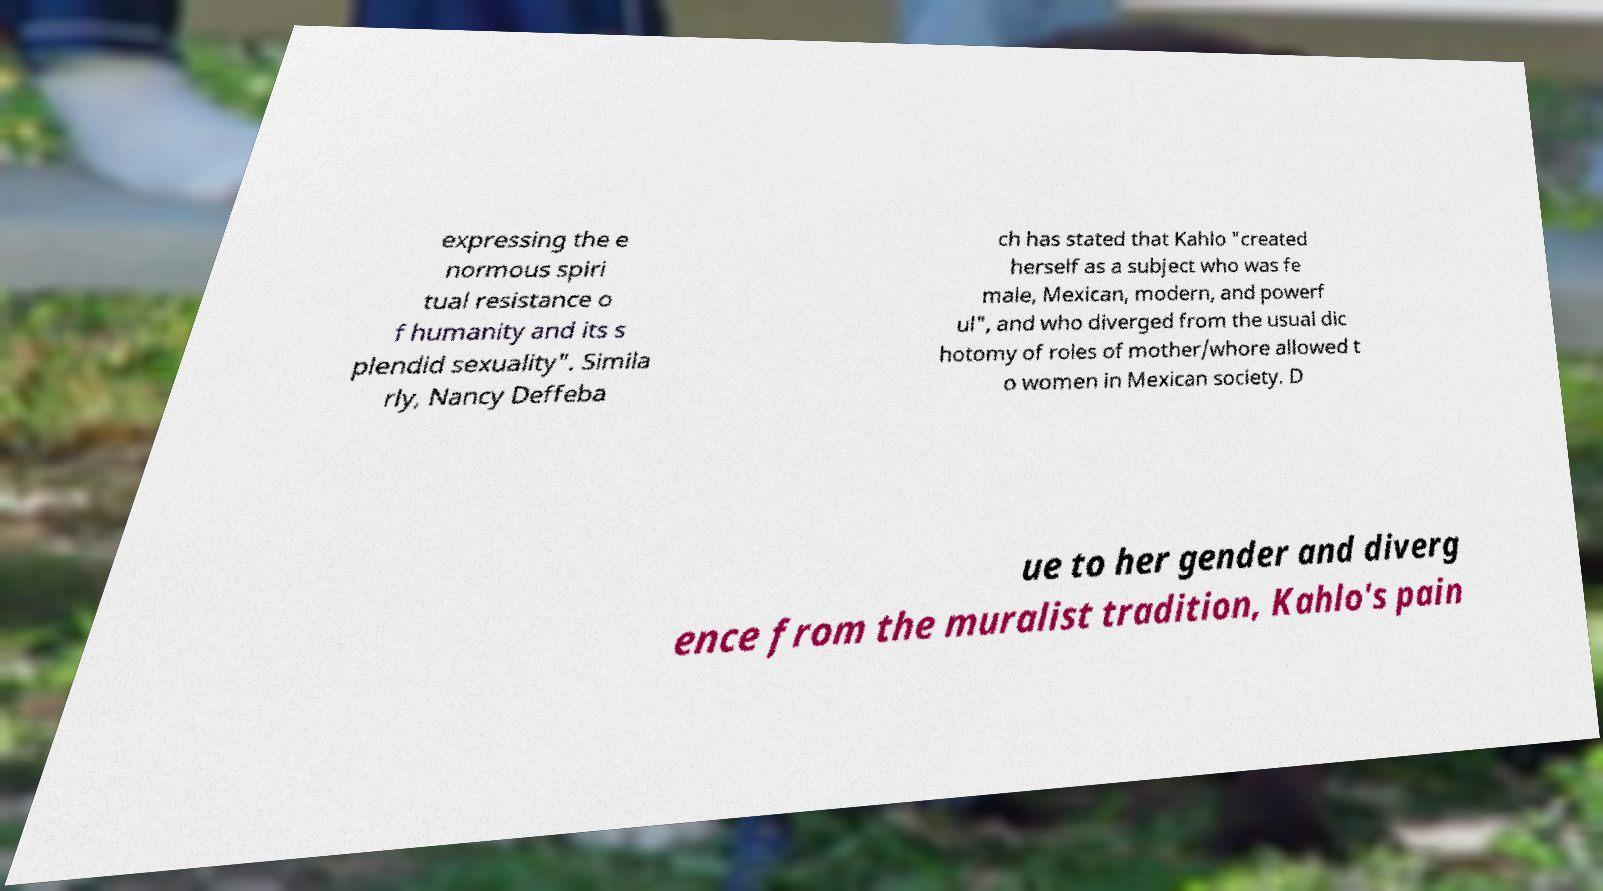Can you read and provide the text displayed in the image?This photo seems to have some interesting text. Can you extract and type it out for me? expressing the e normous spiri tual resistance o f humanity and its s plendid sexuality". Simila rly, Nancy Deffeba ch has stated that Kahlo "created herself as a subject who was fe male, Mexican, modern, and powerf ul", and who diverged from the usual dic hotomy of roles of mother/whore allowed t o women in Mexican society. D ue to her gender and diverg ence from the muralist tradition, Kahlo's pain 